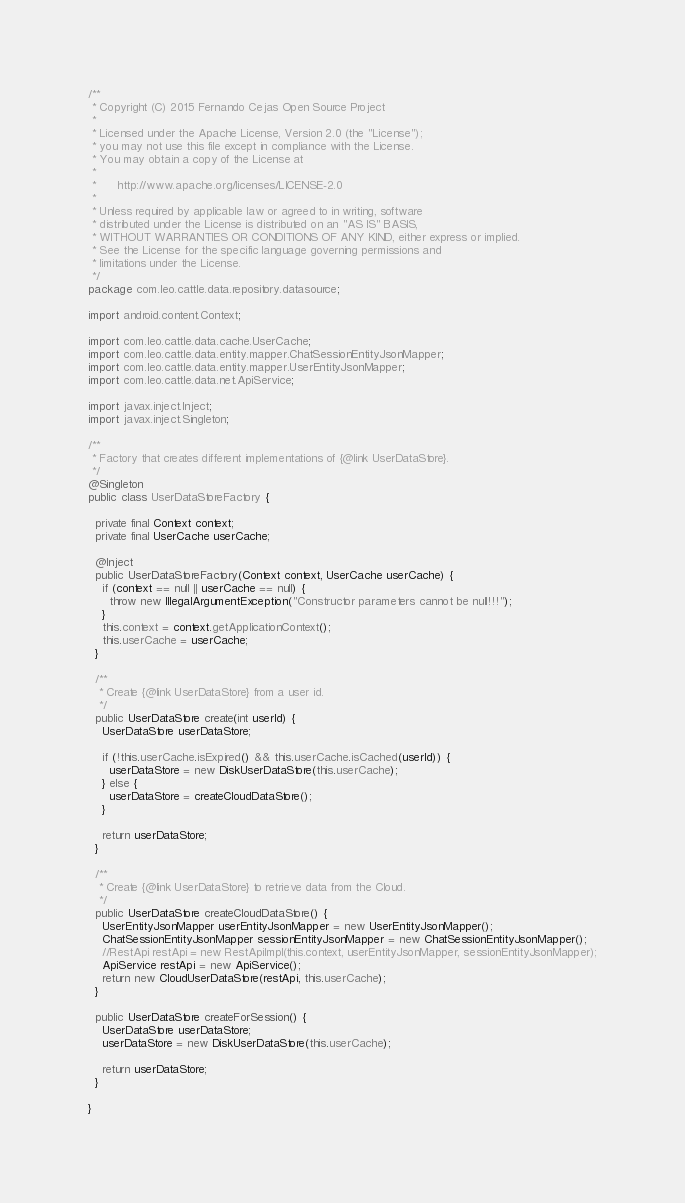<code> <loc_0><loc_0><loc_500><loc_500><_Java_>/**
 * Copyright (C) 2015 Fernando Cejas Open Source Project
 *
 * Licensed under the Apache License, Version 2.0 (the "License");
 * you may not use this file except in compliance with the License.
 * You may obtain a copy of the License at
 *
 *      http://www.apache.org/licenses/LICENSE-2.0
 *
 * Unless required by applicable law or agreed to in writing, software
 * distributed under the License is distributed on an "AS IS" BASIS,
 * WITHOUT WARRANTIES OR CONDITIONS OF ANY KIND, either express or implied.
 * See the License for the specific language governing permissions and
 * limitations under the License.
 */
package com.leo.cattle.data.repository.datasource;

import android.content.Context;

import com.leo.cattle.data.cache.UserCache;
import com.leo.cattle.data.entity.mapper.ChatSessionEntityJsonMapper;
import com.leo.cattle.data.entity.mapper.UserEntityJsonMapper;
import com.leo.cattle.data.net.ApiService;

import javax.inject.Inject;
import javax.inject.Singleton;

/**
 * Factory that creates different implementations of {@link UserDataStore}.
 */
@Singleton
public class UserDataStoreFactory {

  private final Context context;
  private final UserCache userCache;

  @Inject
  public UserDataStoreFactory(Context context, UserCache userCache) {
    if (context == null || userCache == null) {
      throw new IllegalArgumentException("Constructor parameters cannot be null!!!");
    }
    this.context = context.getApplicationContext();
    this.userCache = userCache;
  }

  /**
   * Create {@link UserDataStore} from a user id.
   */
  public UserDataStore create(int userId) {
    UserDataStore userDataStore;

    if (!this.userCache.isExpired() && this.userCache.isCached(userId)) {
      userDataStore = new DiskUserDataStore(this.userCache);
    } else {
      userDataStore = createCloudDataStore();
    }

    return userDataStore;
  }

  /**
   * Create {@link UserDataStore} to retrieve data from the Cloud.
   */
  public UserDataStore createCloudDataStore() {
    UserEntityJsonMapper userEntityJsonMapper = new UserEntityJsonMapper();
    ChatSessionEntityJsonMapper sessionEntityJsonMapper = new ChatSessionEntityJsonMapper();
    //RestApi restApi = new RestApiImpl(this.context, userEntityJsonMapper, sessionEntityJsonMapper);
    ApiService restApi = new ApiService();
    return new CloudUserDataStore(restApi, this.userCache);
  }

  public UserDataStore createForSession() {
    UserDataStore userDataStore;
    userDataStore = new DiskUserDataStore(this.userCache);

    return userDataStore;
  }

}
</code> 